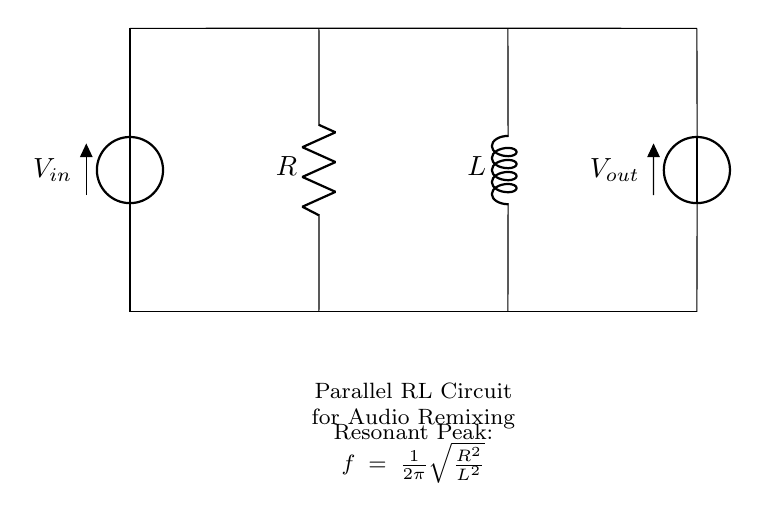What is the input voltage? The input voltage, denoted as V-in in the diagram, is the voltage supplied to the circuit. It is typically a specific level like 5V or 10V specified by the circuit design, but here it's not labeled with a value, so it should be taken as the supply voltage.
Answer: V-in What is the output voltage? The output voltage, denoted as V-out in the circuit, represents the voltage measured across the output terminals. Similar to the input voltage, it may vary based on the input voltage and circuit components but is not specified here.
Answer: V-out What are the components in this circuit? The circuit consists of a resistor and an inductor in parallel configuration, denoted by R and L respectively. These components are standard in a parallel RL circuit used for filtering or resonance applications.
Answer: Resistor and Inductor What is the formula for resonant frequency? The resonant frequency of this parallel RL circuit is given by the formula: f = 1/(2π) * √(R^2/L^2). This formula derives from the relationship between resistance, inductance, and resonant frequency in parallel circuits.
Answer: f = 1/(2π) * √(R^2/L^2) What is the role of the resistor in this circuit? The resistor plays a crucial role in controlling the current flow and affecting the quality factor (Q) of the circuit, which in turn impacts the sharpness of the resonance peak. A higher resistance will lower the peak magnitude and bandwidth.
Answer: Current control How does changing the inductor value affect the resonant frequency? Increasing the inductance value (L) will lower the resonant frequency (f), as seen from the formula: f = 1/(2π) * √(R^2/L^2). Conversely, decreasing L raises the resonant frequency. This change affects how the circuit reacts to different audio frequencies, which is important for audio remixing applications.
Answer: Lower frequency with higher L 